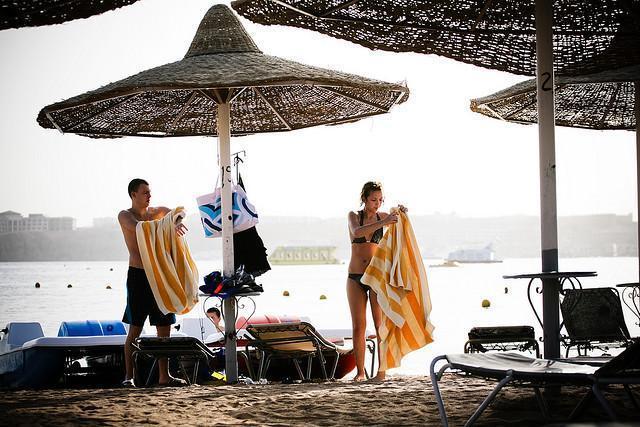How many chairs are in the photo?
Give a very brief answer. 4. How many people can be seen?
Give a very brief answer. 2. How many umbrellas can you see?
Give a very brief answer. 4. How many trains on the track?
Give a very brief answer. 0. 